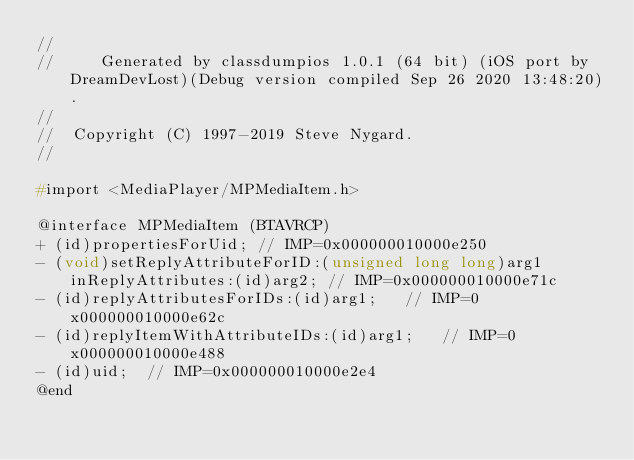<code> <loc_0><loc_0><loc_500><loc_500><_C_>//
//     Generated by classdumpios 1.0.1 (64 bit) (iOS port by DreamDevLost)(Debug version compiled Sep 26 2020 13:48:20).
//
//  Copyright (C) 1997-2019 Steve Nygard.
//

#import <MediaPlayer/MPMediaItem.h>

@interface MPMediaItem (BTAVRCP)
+ (id)propertiesForUid;	// IMP=0x000000010000e250
- (void)setReplyAttributeForID:(unsigned long long)arg1 inReplyAttributes:(id)arg2;	// IMP=0x000000010000e71c
- (id)replyAttributesForIDs:(id)arg1;	// IMP=0x000000010000e62c
- (id)replyItemWithAttributeIDs:(id)arg1;	// IMP=0x000000010000e488
- (id)uid;	// IMP=0x000000010000e2e4
@end

</code> 